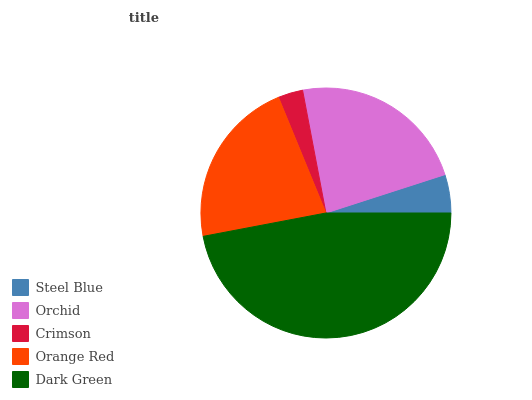Is Crimson the minimum?
Answer yes or no. Yes. Is Dark Green the maximum?
Answer yes or no. Yes. Is Orchid the minimum?
Answer yes or no. No. Is Orchid the maximum?
Answer yes or no. No. Is Orchid greater than Steel Blue?
Answer yes or no. Yes. Is Steel Blue less than Orchid?
Answer yes or no. Yes. Is Steel Blue greater than Orchid?
Answer yes or no. No. Is Orchid less than Steel Blue?
Answer yes or no. No. Is Orange Red the high median?
Answer yes or no. Yes. Is Orange Red the low median?
Answer yes or no. Yes. Is Dark Green the high median?
Answer yes or no. No. Is Crimson the low median?
Answer yes or no. No. 